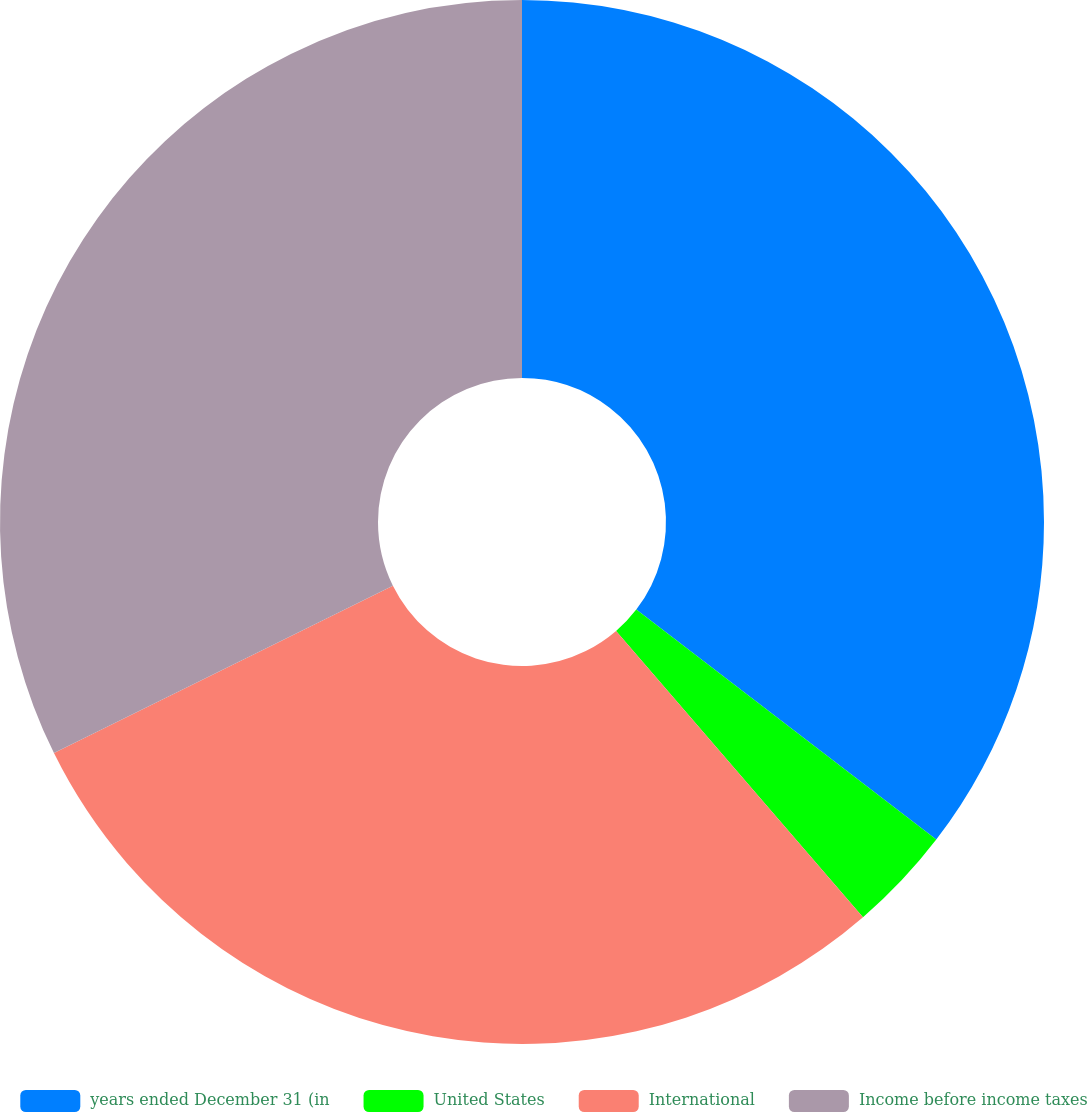<chart> <loc_0><loc_0><loc_500><loc_500><pie_chart><fcel>years ended December 31 (in<fcel>United States<fcel>International<fcel>Income before income taxes<nl><fcel>35.41%<fcel>3.26%<fcel>29.03%<fcel>32.3%<nl></chart> 